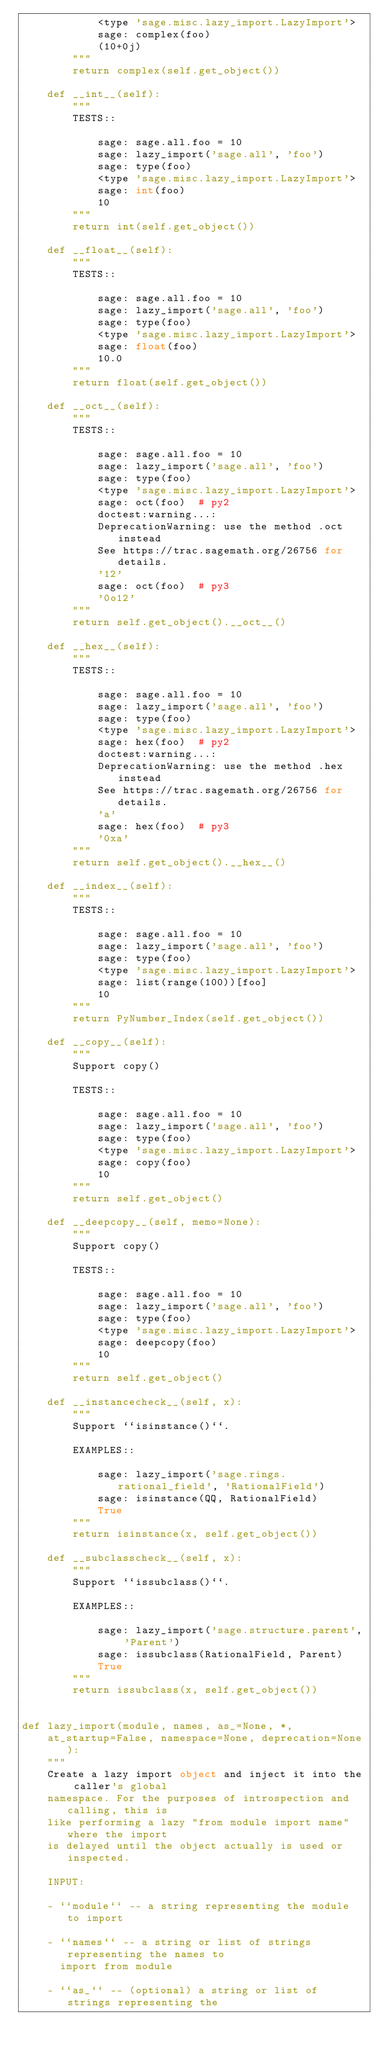Convert code to text. <code><loc_0><loc_0><loc_500><loc_500><_Cython_>            <type 'sage.misc.lazy_import.LazyImport'>
            sage: complex(foo)
            (10+0j)
        """
        return complex(self.get_object())

    def __int__(self):
        """
        TESTS::

            sage: sage.all.foo = 10
            sage: lazy_import('sage.all', 'foo')
            sage: type(foo)
            <type 'sage.misc.lazy_import.LazyImport'>
            sage: int(foo)
            10
        """
        return int(self.get_object())

    def __float__(self):
        """
        TESTS::

            sage: sage.all.foo = 10
            sage: lazy_import('sage.all', 'foo')
            sage: type(foo)
            <type 'sage.misc.lazy_import.LazyImport'>
            sage: float(foo)
            10.0
        """
        return float(self.get_object())

    def __oct__(self):
        """
        TESTS::

            sage: sage.all.foo = 10
            sage: lazy_import('sage.all', 'foo')
            sage: type(foo)
            <type 'sage.misc.lazy_import.LazyImport'>
            sage: oct(foo)  # py2
            doctest:warning...:
            DeprecationWarning: use the method .oct instead
            See https://trac.sagemath.org/26756 for details.
            '12'
            sage: oct(foo)  # py3
            '0o12'
        """
        return self.get_object().__oct__()

    def __hex__(self):
        """
        TESTS::

            sage: sage.all.foo = 10
            sage: lazy_import('sage.all', 'foo')
            sage: type(foo)
            <type 'sage.misc.lazy_import.LazyImport'>
            sage: hex(foo)  # py2
            doctest:warning...:
            DeprecationWarning: use the method .hex instead
            See https://trac.sagemath.org/26756 for details.
            'a'
            sage: hex(foo)  # py3
            '0xa'
        """
        return self.get_object().__hex__()

    def __index__(self):
        """
        TESTS::

            sage: sage.all.foo = 10
            sage: lazy_import('sage.all', 'foo')
            sage: type(foo)
            <type 'sage.misc.lazy_import.LazyImport'>
            sage: list(range(100))[foo]
            10
        """
        return PyNumber_Index(self.get_object())

    def __copy__(self):
        """
        Support copy()

        TESTS::

            sage: sage.all.foo = 10
            sage: lazy_import('sage.all', 'foo')
            sage: type(foo)
            <type 'sage.misc.lazy_import.LazyImport'>
            sage: copy(foo)
            10
        """
        return self.get_object()

    def __deepcopy__(self, memo=None):
        """
        Support copy()

        TESTS::

            sage: sage.all.foo = 10
            sage: lazy_import('sage.all', 'foo')
            sage: type(foo)
            <type 'sage.misc.lazy_import.LazyImport'>
            sage: deepcopy(foo)
            10
        """
        return self.get_object()

    def __instancecheck__(self, x):
        """
        Support ``isinstance()``.

        EXAMPLES::

            sage: lazy_import('sage.rings.rational_field', 'RationalField')
            sage: isinstance(QQ, RationalField)
            True
        """
        return isinstance(x, self.get_object())

    def __subclasscheck__(self, x):
        """
        Support ``issubclass()``.

        EXAMPLES::

            sage: lazy_import('sage.structure.parent', 'Parent')
            sage: issubclass(RationalField, Parent)
            True
        """
        return issubclass(x, self.get_object())


def lazy_import(module, names, as_=None, *,
    at_startup=False, namespace=None, deprecation=None):
    """
    Create a lazy import object and inject it into the caller's global
    namespace. For the purposes of introspection and calling, this is
    like performing a lazy "from module import name" where the import
    is delayed until the object actually is used or inspected.

    INPUT:

    - ``module`` -- a string representing the module to import

    - ``names`` -- a string or list of strings representing the names to
      import from module

    - ``as_`` -- (optional) a string or list of strings representing the</code> 